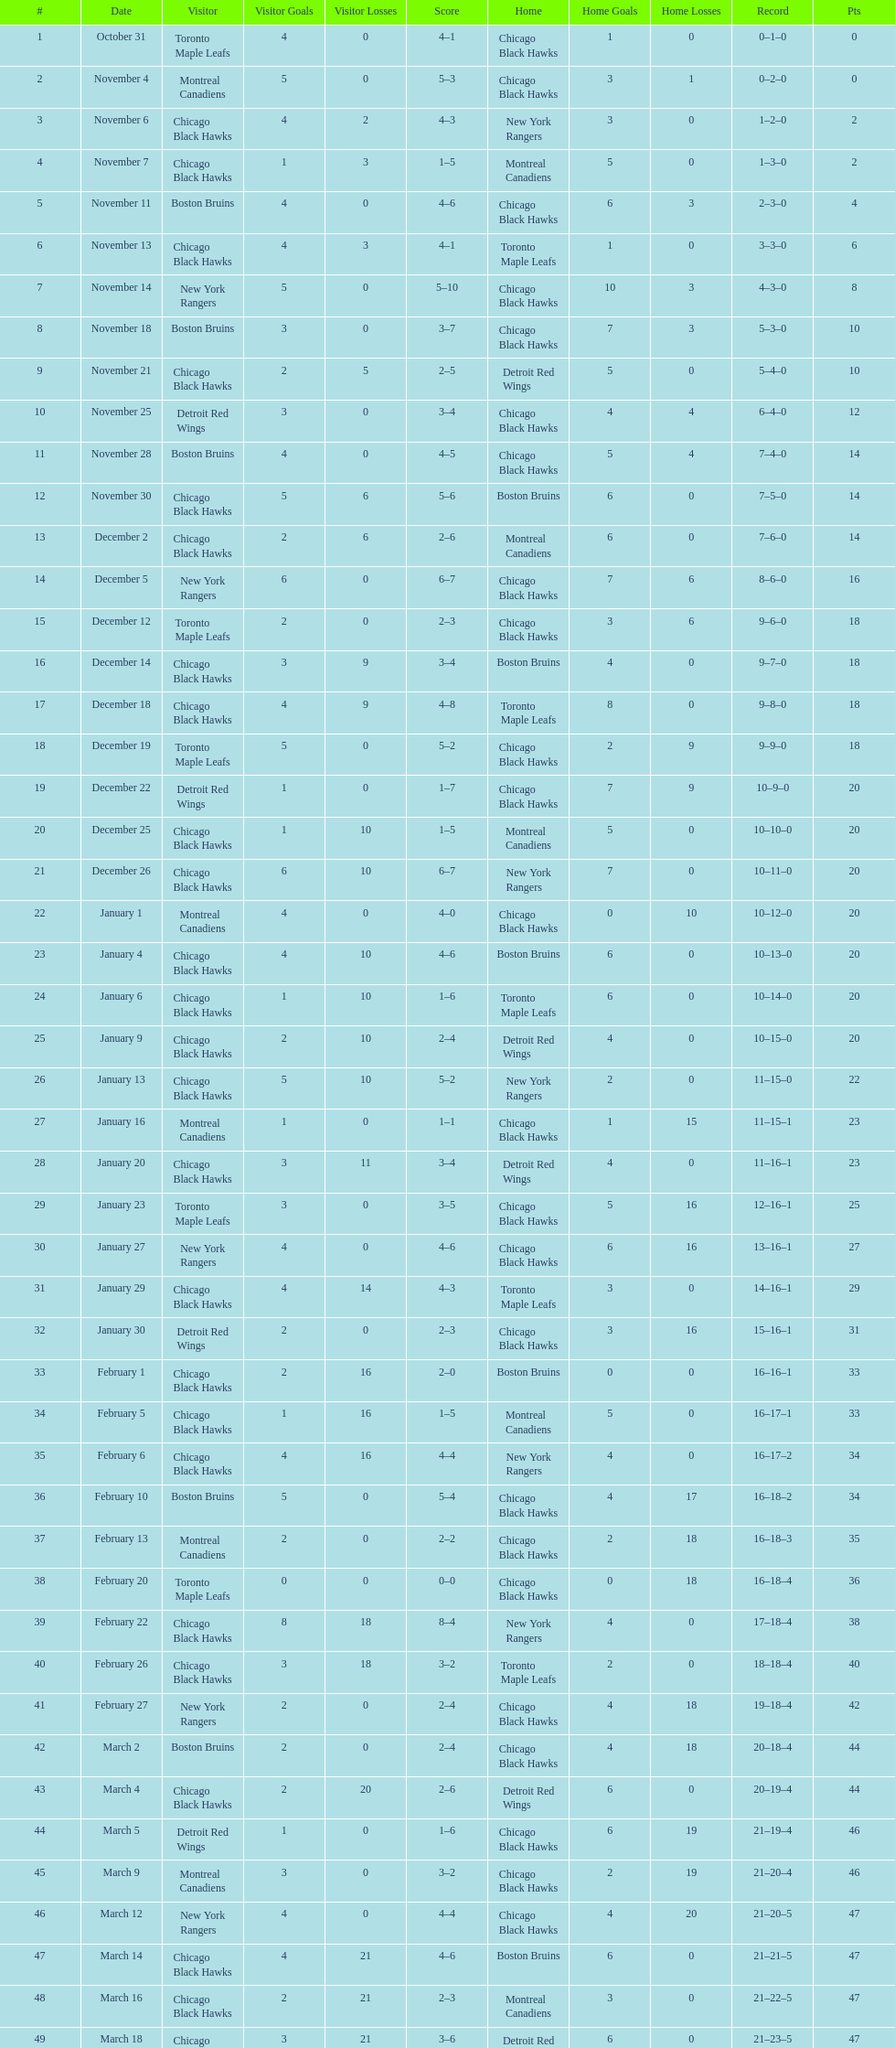How long is the duration of one season (from the first game to the last)? 5 months. 